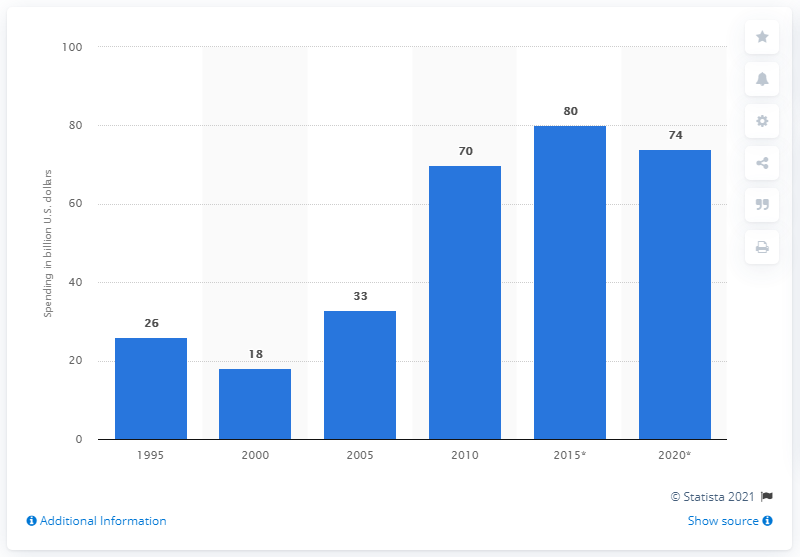Identify some key points in this picture. The amount of money spent on the Supplemental Nutrition Assistance Program (SNAP) in 2010 was $70. 